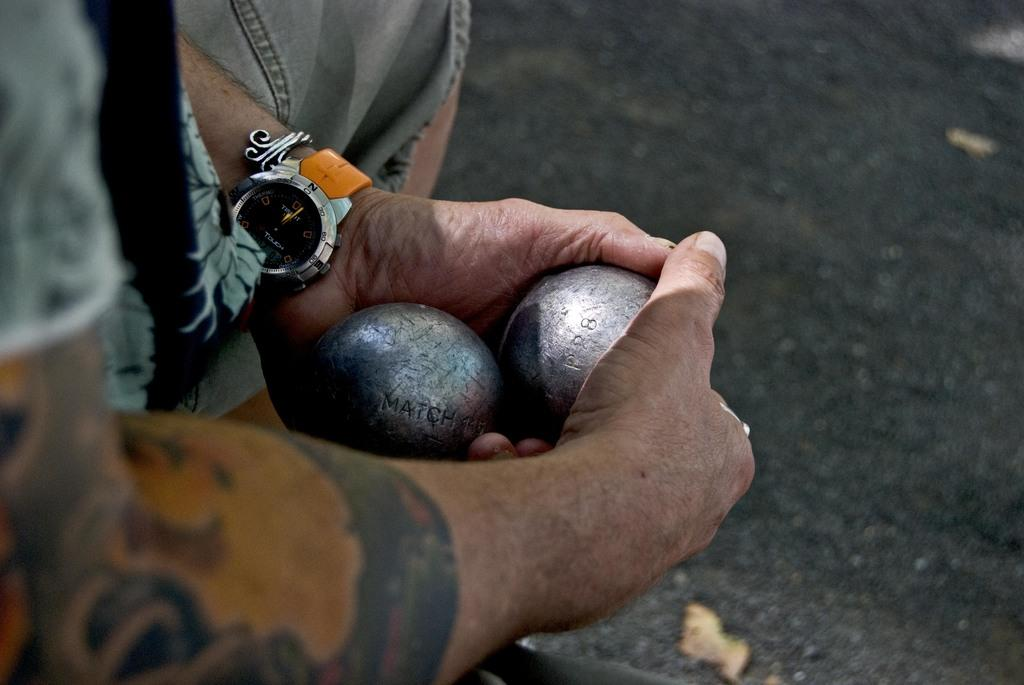<image>
Create a compact narrative representing the image presented. Some male arms holding two silver balls, his watch is displaying the time as 12. 